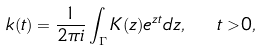Convert formula to latex. <formula><loc_0><loc_0><loc_500><loc_500>k ( t ) = \frac { 1 } { 2 \pi i } \int _ { \Gamma } K ( z ) e ^ { z t } d z , \ \ t > 0 ,</formula> 